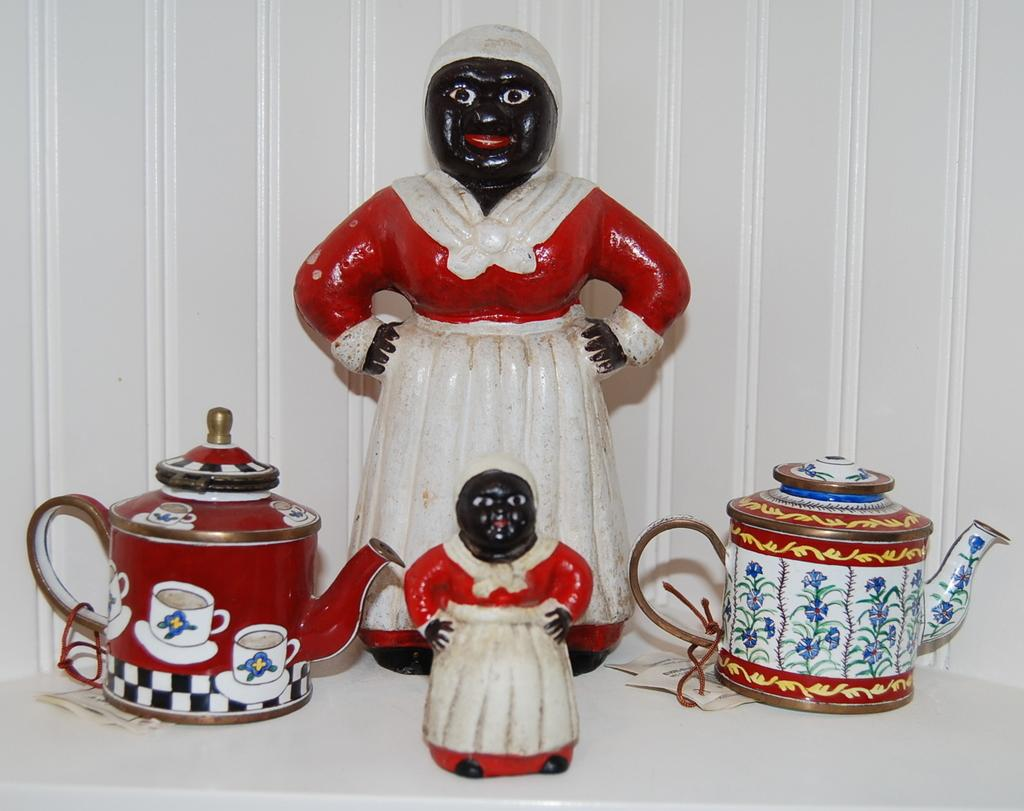What type of toys are present in the image? There are girl toys in the image. What other objects can be seen in the image? There are coffee jugs and papers visible in the image. What is visible in the background of the image? There is a wall in the background of the image. How many toes does the goose have in the image? There is no goose present in the image, so it is not possible to determine the number of toes it might have. 